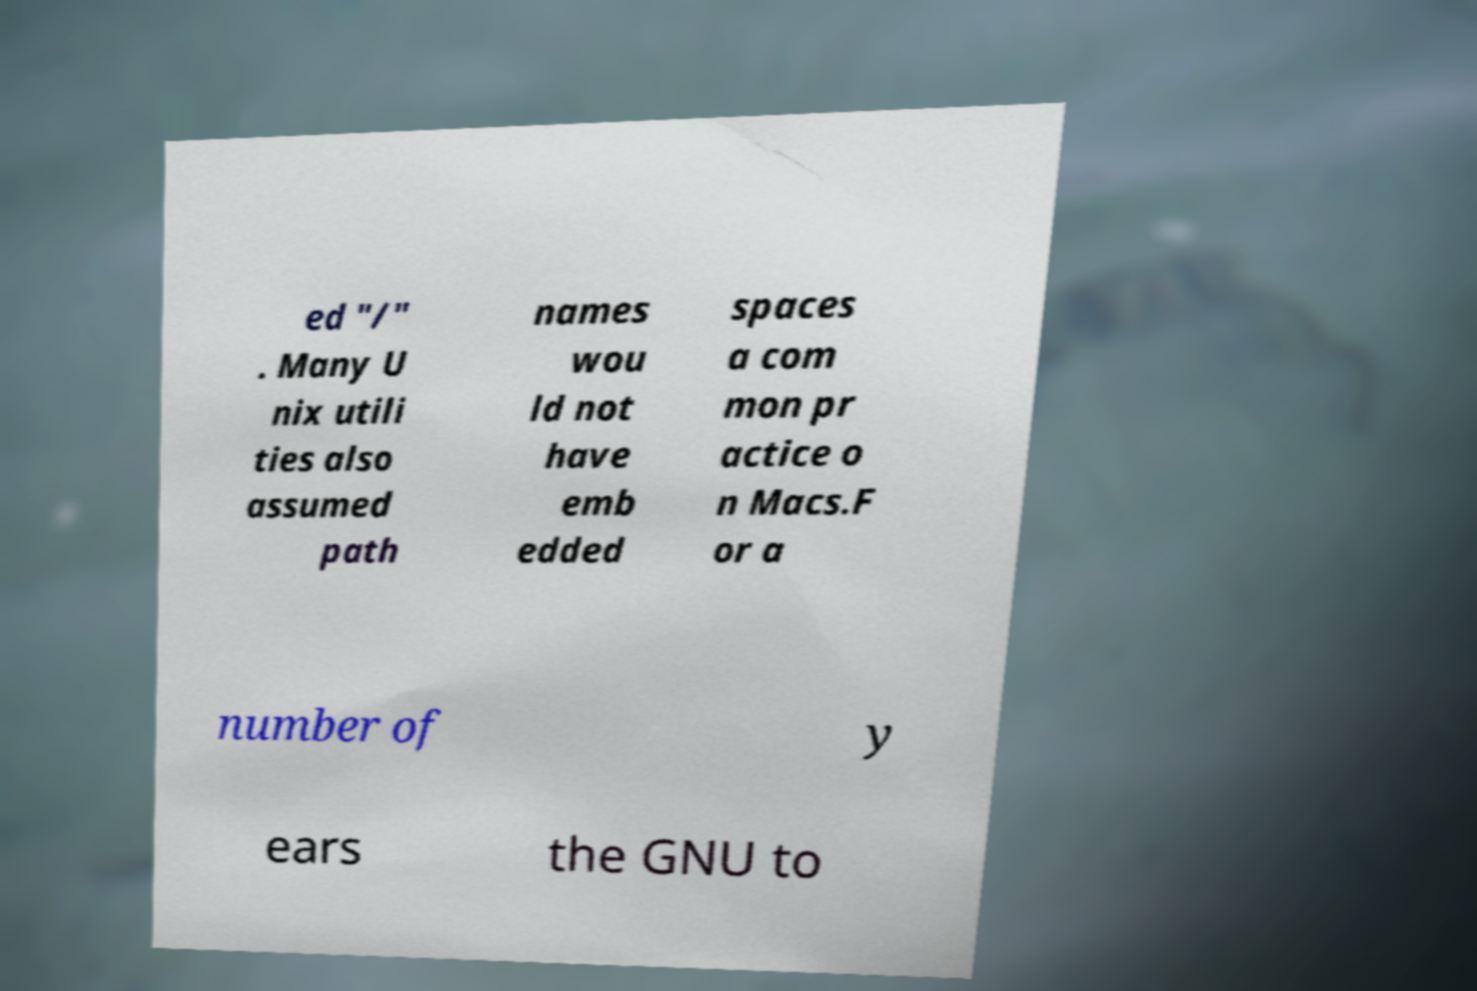There's text embedded in this image that I need extracted. Can you transcribe it verbatim? ed "/" . Many U nix utili ties also assumed path names wou ld not have emb edded spaces a com mon pr actice o n Macs.F or a number of y ears the GNU to 